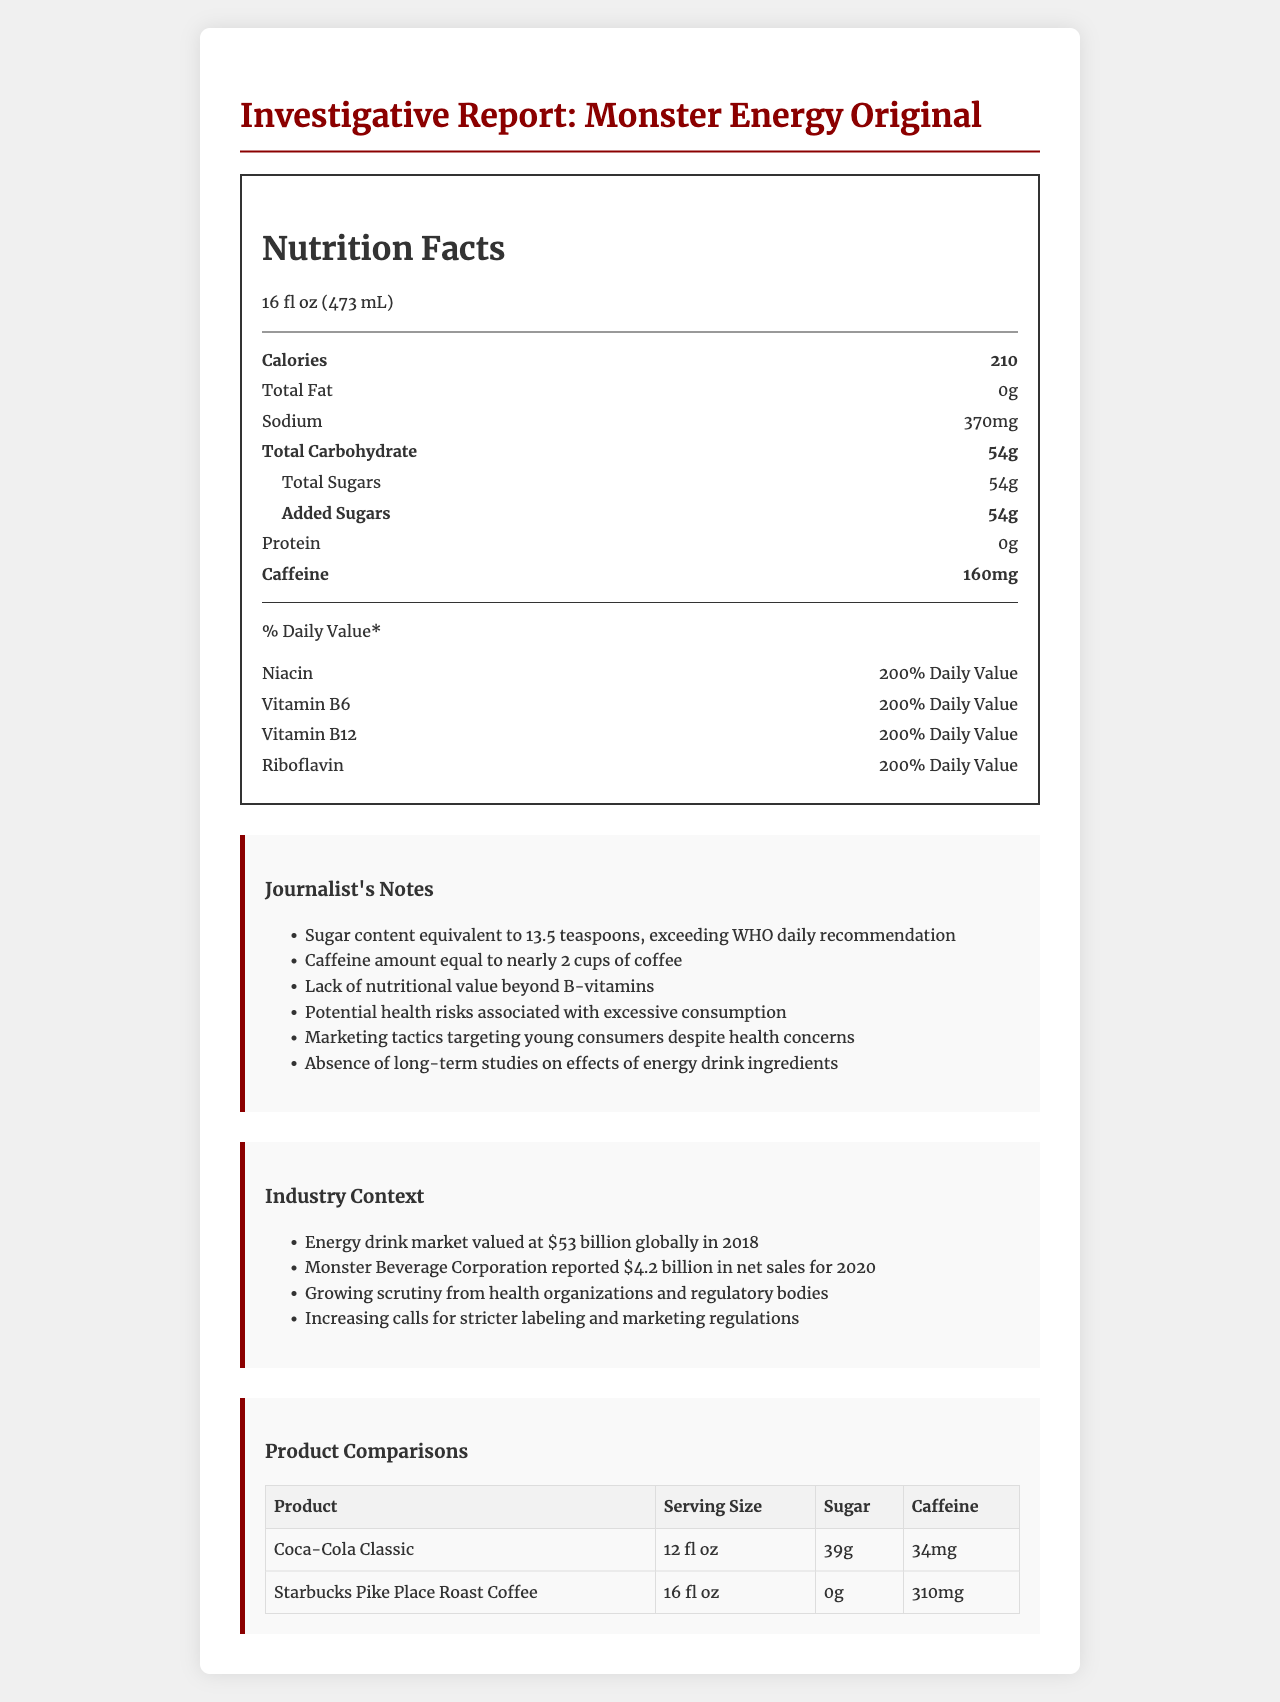what is the serving size of Monster Energy Original? The serving size is stated as "16 fl oz (473 mL)" in the nutrition facts section of the document.
Answer: 16 fl oz (473 mL) how many calories per serving does Monster Energy Original contain? The nutrition facts label states that there are 210 calories per serving.
Answer: 210 how much total sugar is in one serving of Monster Energy Original? The nutrition facts label indicates that the total sugar content per serving is 54 grams.
Answer: 54g what is the sodium content of Monster Energy Original? The nutrition facts label states that the sodium content per serving is 370 mg.
Answer: 370mg how much caffeine is in Monster Energy Original? The nutrition facts label lists 160 mg of caffeine per serving.
Answer: 160mg Compare the sugar content of Monster Energy Original to Coca-Cola Classic The comparisons section shows that Monster Energy Original has 54 grams of sugar, while Coca-Cola Classic has 39 grams.
Answer: Monster Energy: 54g, Coca-Cola Classic: 39g which product has the highest caffeine content? A. Monster Energy Original B. Coca-Cola Classic C. Starbucks Pike Place Roast Coffee The comparison table shows that Starbucks Pike Place Roast Coffee has 310 mg of caffeine, which is higher than both Monster Energy Original (160 mg) and Coca-Cola Classic (34 mg).
Answer: C what is the main source of calories in Monster Energy Original? Monster Energy contains 54 grams of added sugars, which is the main source of its 210 calories.
Answer: Added Sugars is there any fat content in Monster Energy Original? The nutrition facts label indicates there is 0 grams of total fat in Monster Energy Original.
Answer: No is the taurine content in Monster Energy Original higher than the inositol content? The document lists taurine content as 2000 mg and inositol content as 100 mg, making taurine content higher.
Answer: Yes why might health organizations scrutinize Monster Energy Original? The document indicates concerns about the high sugar and caffeine levels, potential health risks, and marketing practices.
Answer: Due to excessive sugar and caffeine content; potential health risks; marketing to young consumers. what is the industry value of the energy drink market globally in 2018? The industry context section mentions that the energy drink market was valued at $53 billion globally in 2018.
Answer: $53 billion how does Monster Energy Original's sugar content compare to WHO's daily recommendation? The journalist notes section highlights that Monster Energy Original's sugar content exceeds the World Health Organization's daily recommendation.
Answer: Exceeds WHO's daily recommendation explain the potential risks of consuming Monster Energy Original excessively The document hints at the health risks associated with excessive sugar and caffeine consumption, such as obesity, heart problems, and potential addictive effects.
Answer: Excessive sugar and caffeine can lead to health issues like obesity, heart problems, and addiction. summarize the main findings of the document The document provides detailed insights into the nutritional content of Monster Energy Original, particularly its high sugar and caffeine levels, compares it with other beverages, and discusses industry context and health concerns.
Answer: Monster Energy Original has a high sugar (54g) and caffeine (160mg) content, which raises health concerns. It also highlights the market context and comparisons with other beverages. who are the main targets of Monster Energy's marketing tactics? The document implies targeting young consumers but does not provide specific details about the targeted demographic.
Answer: Cannot be determined 